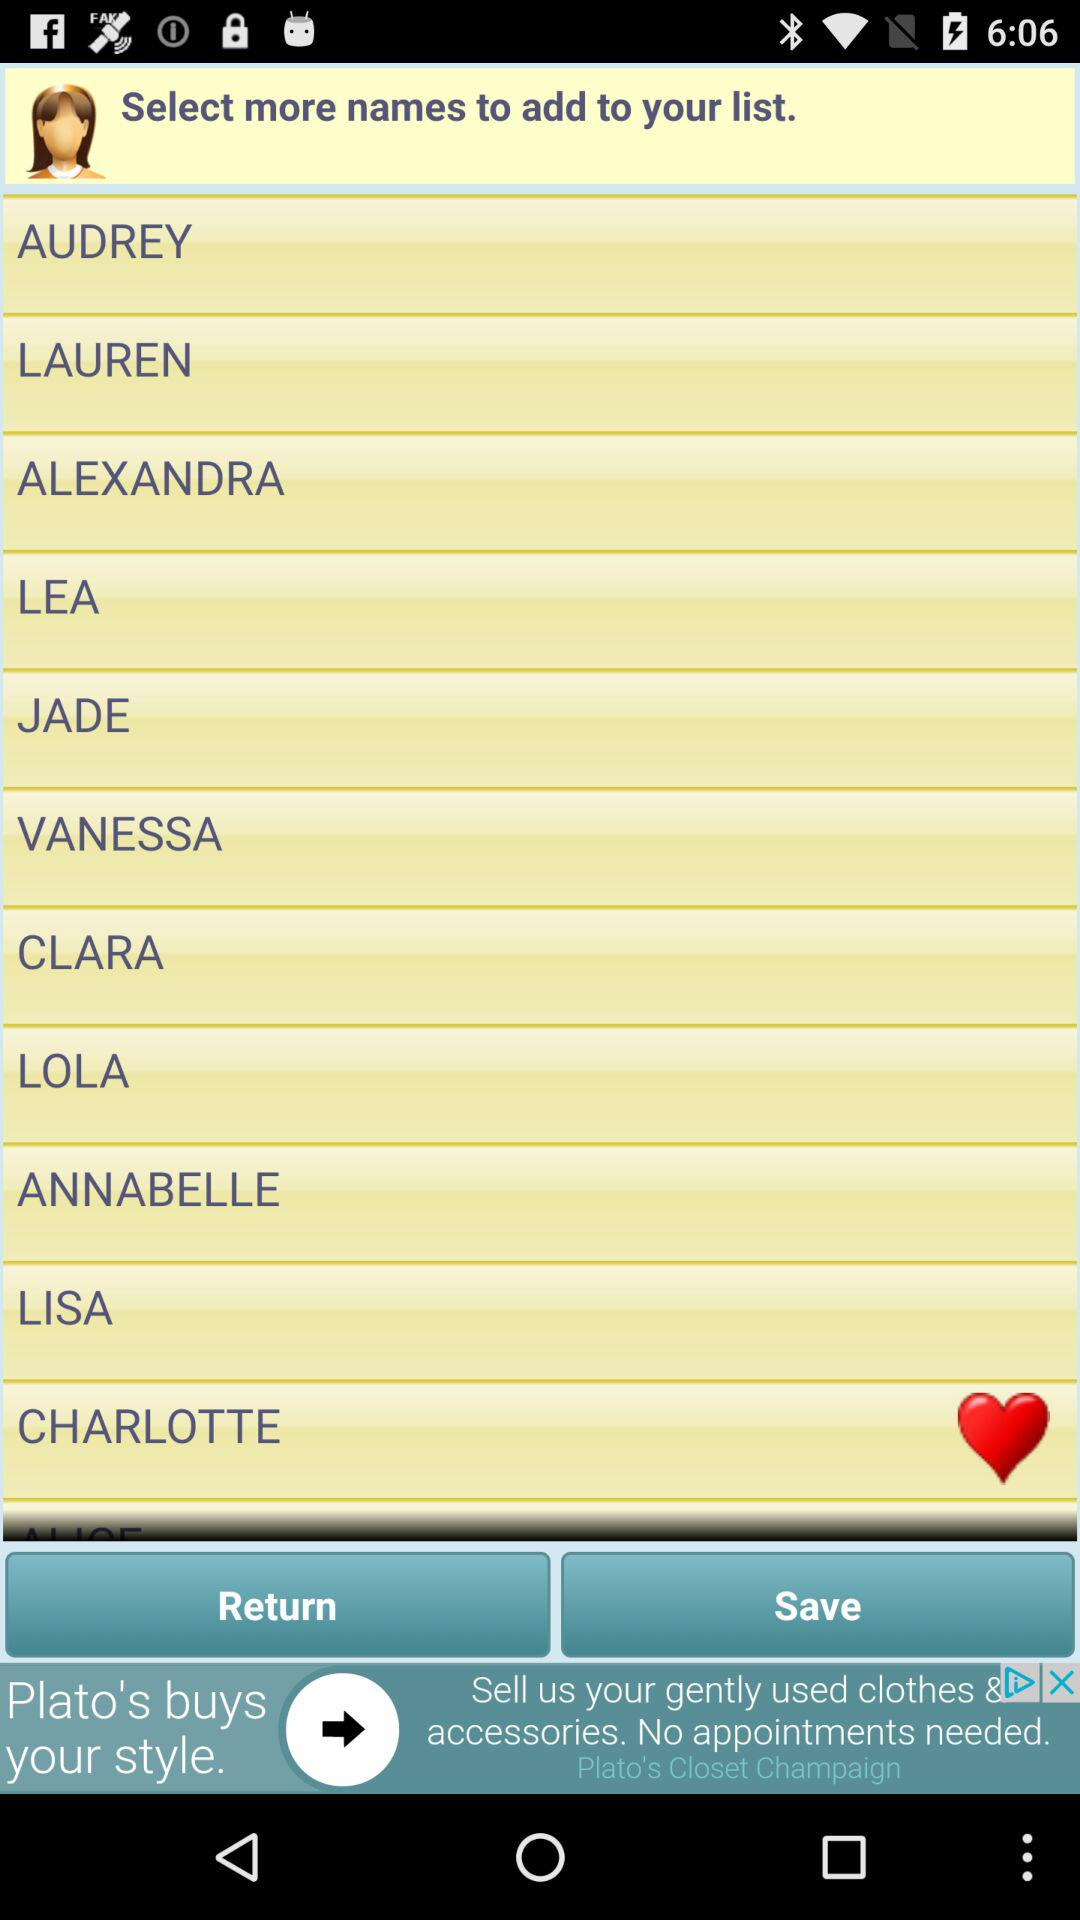What purpose might this app serve based on the interface shown? The app interface suggests it could be a social or shopping application where users can select from curated lists, such as popular names for a list possibly used in games or profiles, or even preferences in a community engagement tool. 